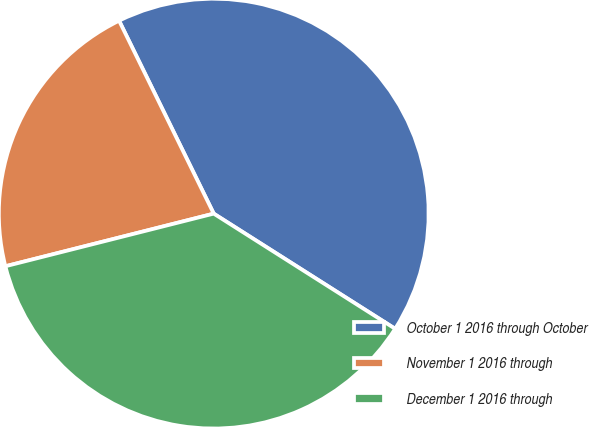Convert chart. <chart><loc_0><loc_0><loc_500><loc_500><pie_chart><fcel>October 1 2016 through October<fcel>November 1 2016 through<fcel>December 1 2016 through<nl><fcel>41.26%<fcel>21.68%<fcel>37.06%<nl></chart> 